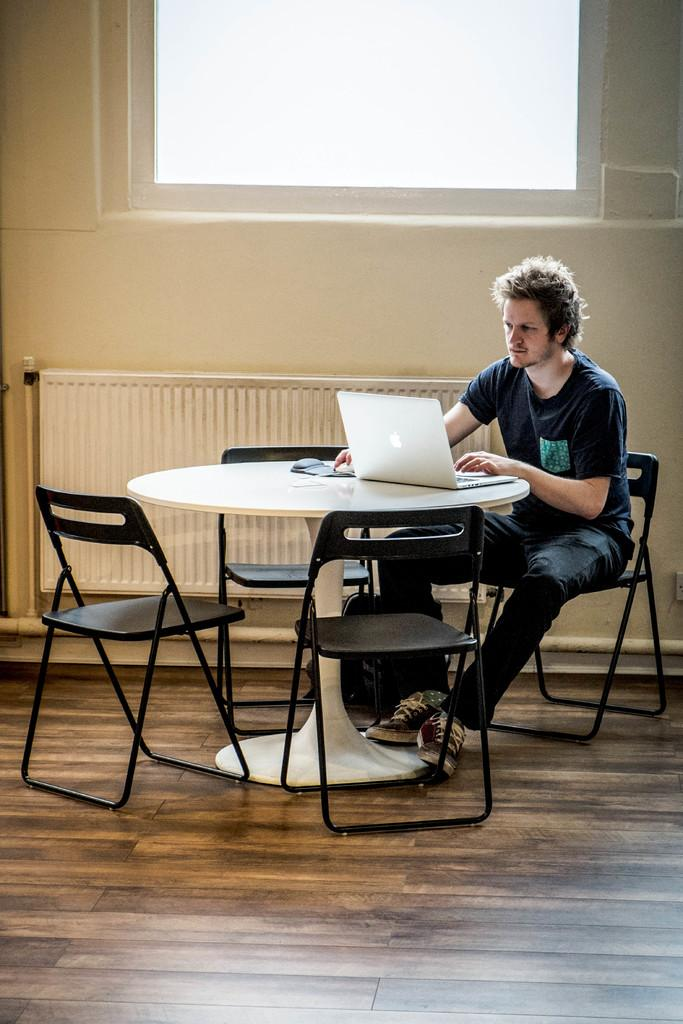What is the person in the image doing? The person is sitting on a chair and using a laptop. How many chairs are visible in the image? There are four chairs around a table in the image. What might the person be using the laptop for? It is not possible to determine what the person is using the laptop for from the image alone. What type of soap is on the table in the image? There is no soap present in the image. How many leaves are on the table in the image? There are no leaves present in the image. 